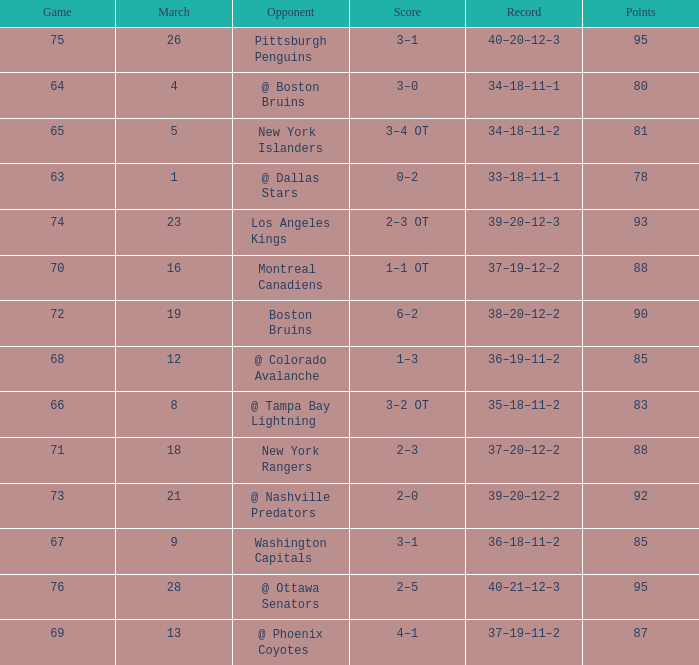Which Opponent has a Record of 38–20–12–2? Boston Bruins. 